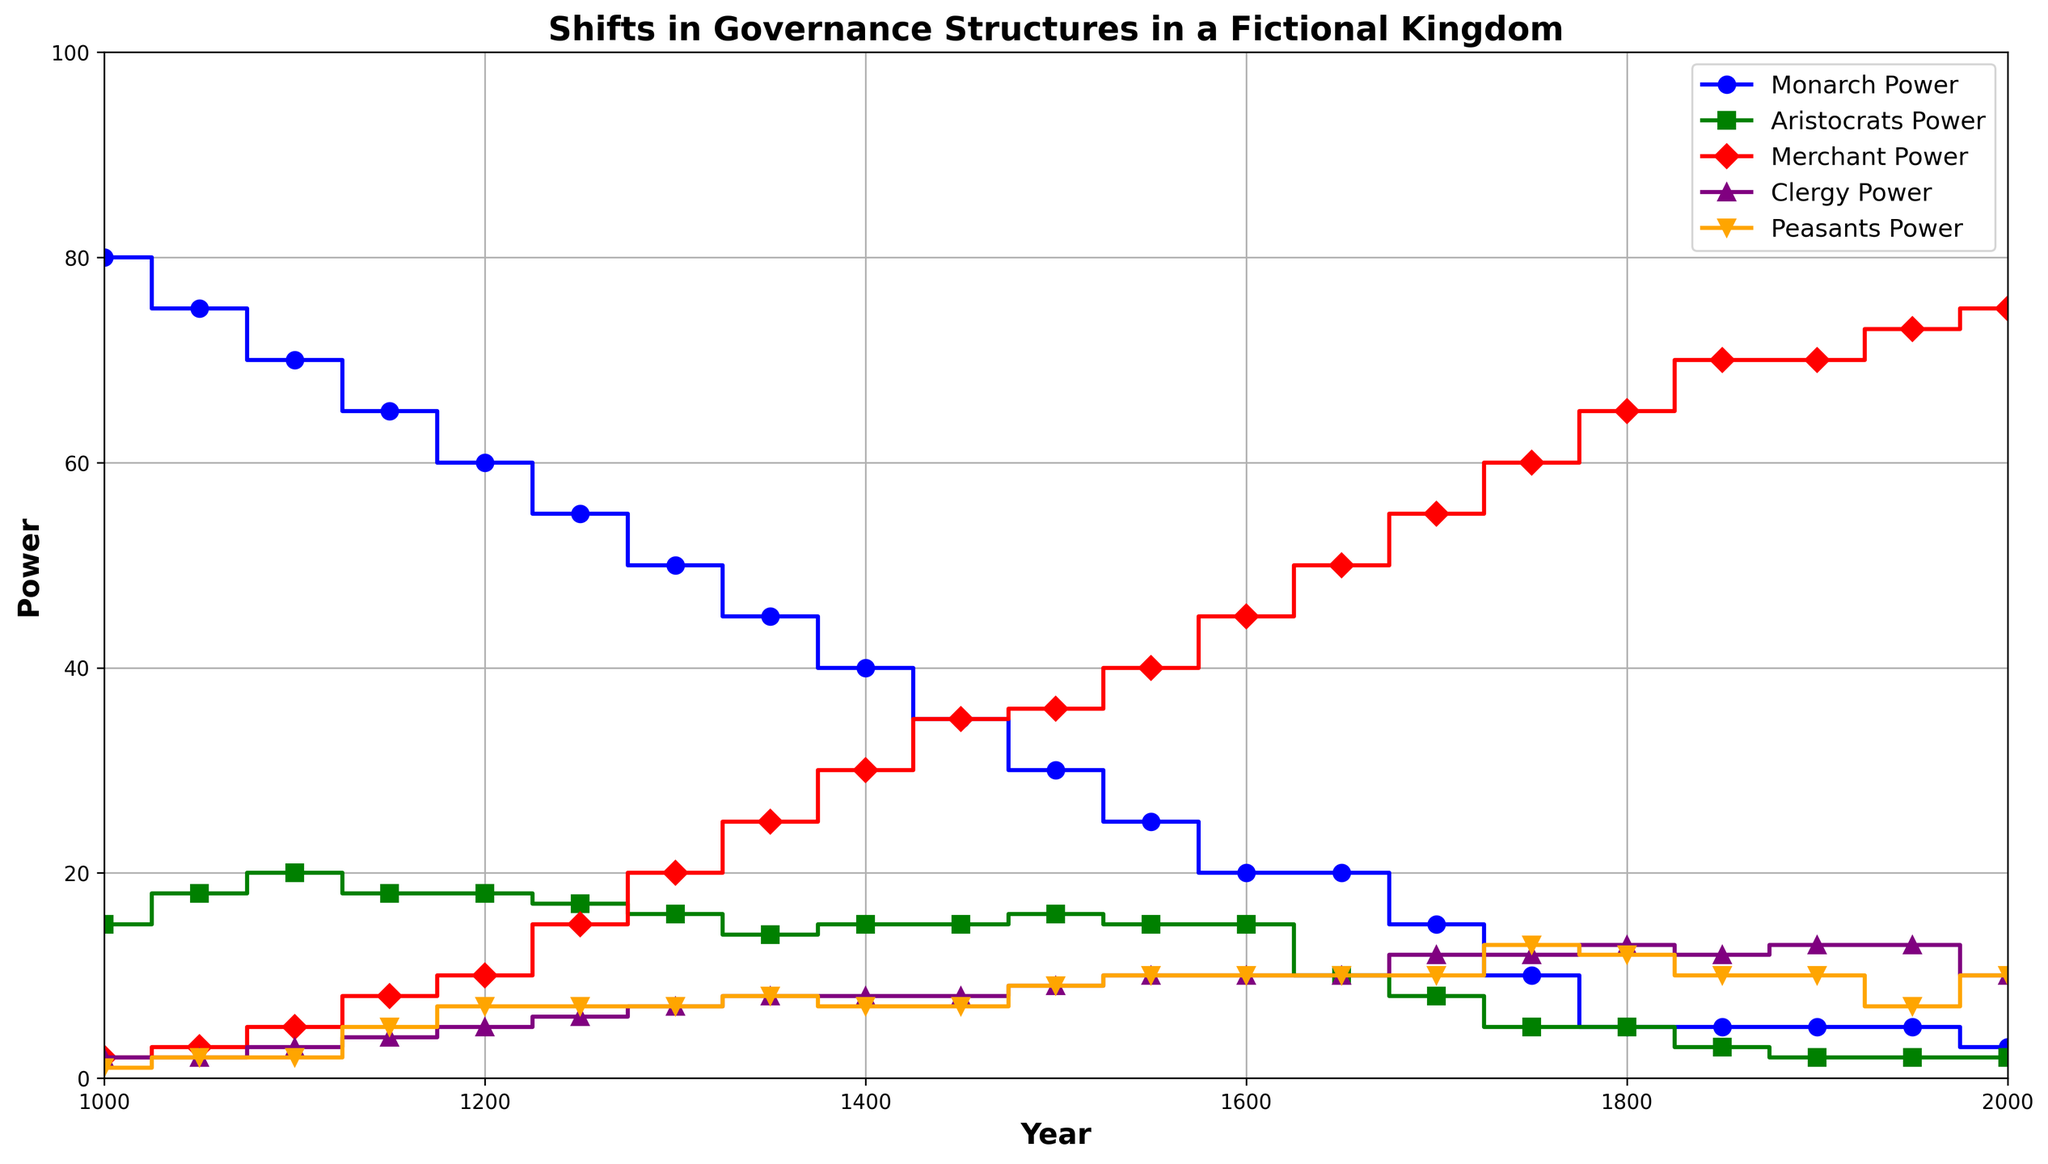What's the general trend of Monarch Power over time? Observe the blue line representing Monarch Power on the plot. It starts high at around 80 in the year 1000 and gradually declines to around 3 by the year 2000. This indicates a general downward trend.
Answer: Decreasing Which group had the highest power in the year 1750? Look at the data points for the year 1750. The red line representing Merchant Power is around 60, which is the highest compared to Monarch, Aristocrats, Clergy, and Peasants.
Answer: Merchants What was the difference in Peasants Power between the years 1150 and 1750? Find the orange line for Peasants Power at 1150 and 1750. At 1150, the power is around 5, and at 1750, it's around 13. The difference is 13 - 5 = 8.
Answer: 8 Which power group had the most stable power level over the entire period? Observe all the lines in the chart. The yellow line representing Clergy Power shows the least fluctuation, staying mostly around 10-13 from 1000 to 2000, indicating stability.
Answer: Clergy In which year did Merchants Power surpass 50 for the first time? Focus on the red line representing Merchants Power. It first crosses the 50 mark between 1600 and 1650, specifically noticeable at 1650.
Answer: 1650 How did the power of Aristocrats change between the years 1500 and 1650? Check the green line for Aristocrats Power at 1500 and 1650. In 1500, it is about 16, and by 1650, it drops to around 10. The change is a decrease of 16 - 10 = 6 units.
Answer: Decreased by 6 Compare the power of Clergy and Peasants in the year 1900. Which was higher? In the year 1900, find the points on the purple line for Clergy and the orange line for Peasants. Clergy Power is around 13, whereas Peasants Power is around 10.
Answer: Clergy What can be observed about the correlation between Monarch Power and Merchant Power? Observe the blue line of Monarch Power and the red line of Merchant Power. As Monarch Power decreases, Merchant Power generally increases, indicating an inverse relationship.
Answer: Inversely correlated Which group showed the most significant increase in power over the observed period? Compare the slopes of all lines from the beginning (1000) to the end (2000). The red line for Merchants goes from around 2 to 75, showing the most significant increase by 73 units.
Answer: Merchants What was the approximate power level of the Aristocrats during the midpoint of the total timespan? The midpoint year between 1000 and 2000 is 1500. Check the green line at 1500, which shows an Aristocrats Power level of around 16.
Answer: 16 